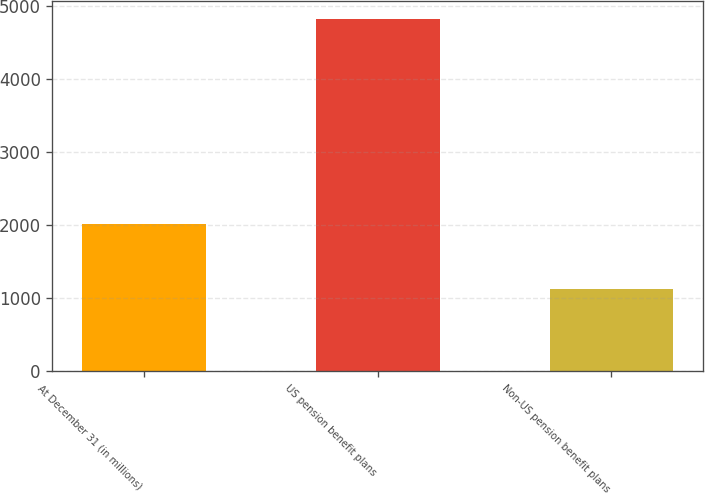Convert chart. <chart><loc_0><loc_0><loc_500><loc_500><bar_chart><fcel>At December 31 (in millions)<fcel>US pension benefit plans<fcel>Non-US pension benefit plans<nl><fcel>2012<fcel>4827<fcel>1125<nl></chart> 